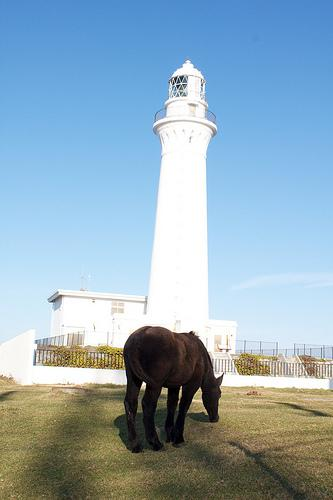Question: where was this photo taken?
Choices:
A. Beside a lighthouse.
B. On the waterfront.
C. By the tree.
D. Next to the picnic table.
Answer with the letter. Answer: A 